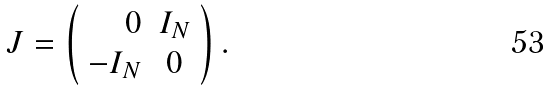Convert formula to latex. <formula><loc_0><loc_0><loc_500><loc_500>J = \left ( \begin{array} { r c l } 0 & I _ { N } \\ - I _ { N } & 0 \end{array} \right ) .</formula> 